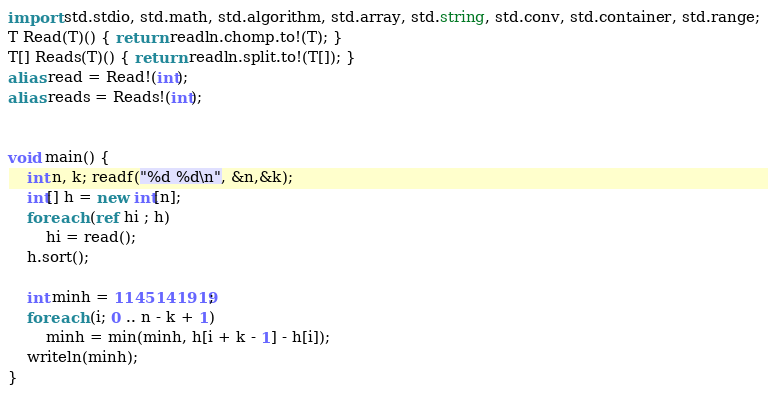<code> <loc_0><loc_0><loc_500><loc_500><_D_>import std.stdio, std.math, std.algorithm, std.array, std.string, std.conv, std.container, std.range;
T Read(T)() { return readln.chomp.to!(T); }
T[] Reads(T)() { return readln.split.to!(T[]); }
alias read = Read!(int);
alias reads = Reads!(int);


void main() {
    int n, k; readf("%d %d\n", &n,&k);
    int[] h = new int[n];
    foreach (ref hi ; h)
        hi = read();
    h.sort();

    int minh = 1145141919;
    foreach (i; 0 .. n - k + 1)
        minh = min(minh, h[i + k - 1] - h[i]);
    writeln(minh);
}
</code> 